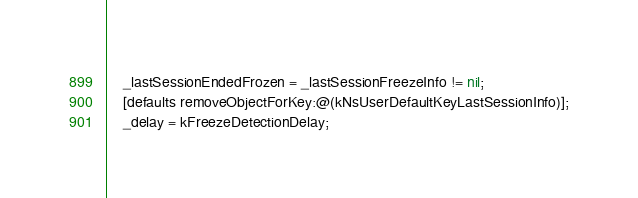<code> <loc_0><loc_0><loc_500><loc_500><_ObjectiveC_>    _lastSessionEndedFrozen = _lastSessionFreezeInfo != nil;
    [defaults removeObjectForKey:@(kNsUserDefaultKeyLastSessionInfo)];
    _delay = kFreezeDetectionDelay;</code> 